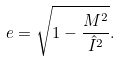<formula> <loc_0><loc_0><loc_500><loc_500>e = \sqrt { 1 - \frac { M ^ { 2 } } { \hat { I } ^ { 2 } } } .</formula> 